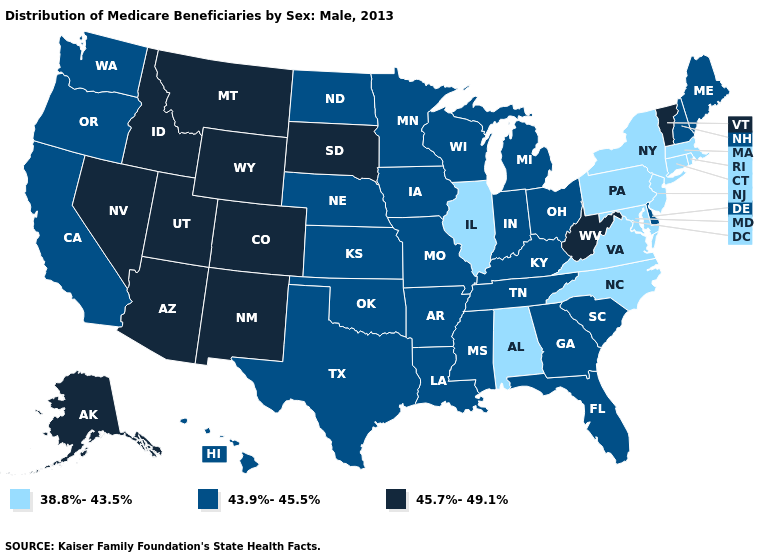How many symbols are there in the legend?
Short answer required. 3. Name the states that have a value in the range 38.8%-43.5%?
Write a very short answer. Alabama, Connecticut, Illinois, Maryland, Massachusetts, New Jersey, New York, North Carolina, Pennsylvania, Rhode Island, Virginia. Does Delaware have the highest value in the South?
Concise answer only. No. Name the states that have a value in the range 45.7%-49.1%?
Short answer required. Alaska, Arizona, Colorado, Idaho, Montana, Nevada, New Mexico, South Dakota, Utah, Vermont, West Virginia, Wyoming. Does Vermont have the highest value in the Northeast?
Give a very brief answer. Yes. What is the value of Louisiana?
Short answer required. 43.9%-45.5%. What is the highest value in the USA?
Quick response, please. 45.7%-49.1%. What is the highest value in states that border Arkansas?
Keep it brief. 43.9%-45.5%. Name the states that have a value in the range 38.8%-43.5%?
Quick response, please. Alabama, Connecticut, Illinois, Maryland, Massachusetts, New Jersey, New York, North Carolina, Pennsylvania, Rhode Island, Virginia. Does New Hampshire have the highest value in the Northeast?
Answer briefly. No. Does Mississippi have the same value as Louisiana?
Write a very short answer. Yes. What is the lowest value in the USA?
Keep it brief. 38.8%-43.5%. Does Alabama have the lowest value in the USA?
Be succinct. Yes. What is the value of California?
Quick response, please. 43.9%-45.5%. What is the lowest value in the South?
Keep it brief. 38.8%-43.5%. 